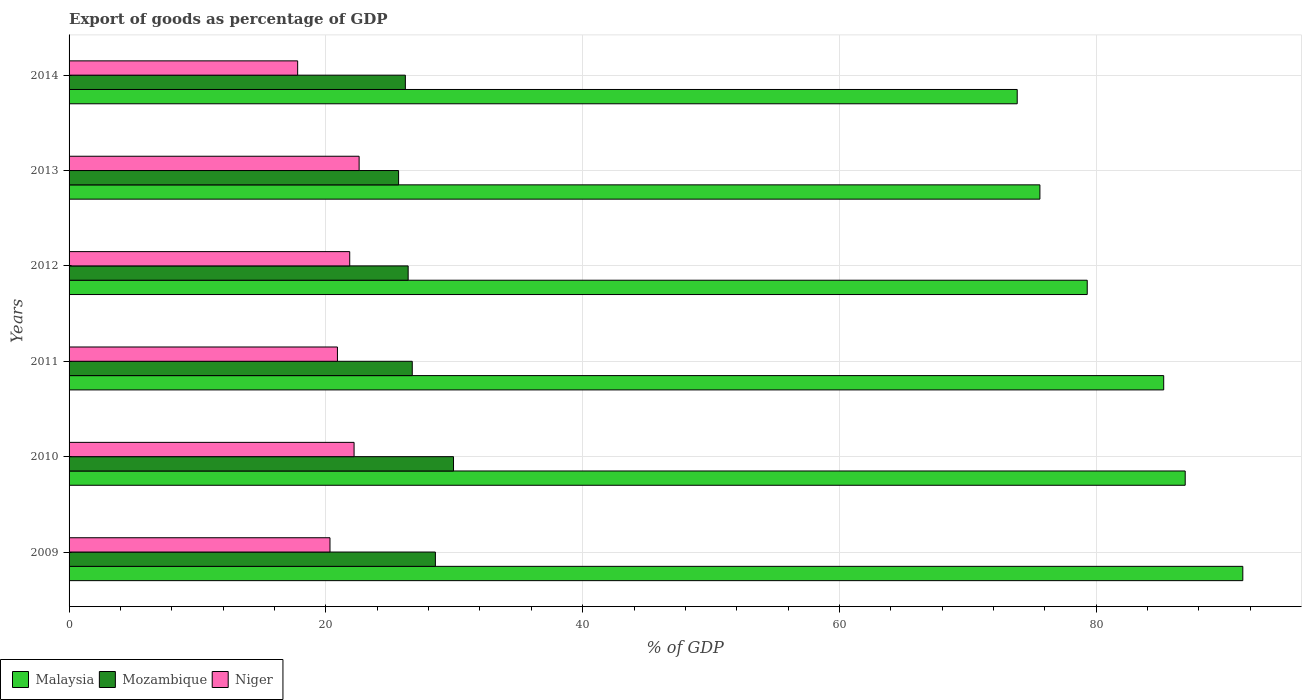How many different coloured bars are there?
Give a very brief answer. 3. How many groups of bars are there?
Keep it short and to the point. 6. Are the number of bars per tick equal to the number of legend labels?
Your answer should be compact. Yes. How many bars are there on the 1st tick from the top?
Provide a succinct answer. 3. What is the label of the 3rd group of bars from the top?
Ensure brevity in your answer.  2012. What is the export of goods as percentage of GDP in Malaysia in 2014?
Give a very brief answer. 73.85. Across all years, what is the maximum export of goods as percentage of GDP in Mozambique?
Your answer should be very brief. 29.94. Across all years, what is the minimum export of goods as percentage of GDP in Niger?
Offer a very short reply. 17.8. In which year was the export of goods as percentage of GDP in Malaysia maximum?
Keep it short and to the point. 2009. What is the total export of goods as percentage of GDP in Niger in the graph?
Provide a succinct answer. 125.68. What is the difference between the export of goods as percentage of GDP in Niger in 2009 and that in 2011?
Offer a terse response. -0.58. What is the difference between the export of goods as percentage of GDP in Mozambique in 2009 and the export of goods as percentage of GDP in Malaysia in 2014?
Offer a very short reply. -45.32. What is the average export of goods as percentage of GDP in Niger per year?
Offer a very short reply. 20.95. In the year 2014, what is the difference between the export of goods as percentage of GDP in Malaysia and export of goods as percentage of GDP in Mozambique?
Offer a very short reply. 47.65. What is the ratio of the export of goods as percentage of GDP in Niger in 2012 to that in 2013?
Provide a short and direct response. 0.97. Is the export of goods as percentage of GDP in Niger in 2011 less than that in 2014?
Provide a short and direct response. No. What is the difference between the highest and the second highest export of goods as percentage of GDP in Mozambique?
Provide a short and direct response. 1.41. What is the difference between the highest and the lowest export of goods as percentage of GDP in Mozambique?
Provide a succinct answer. 4.28. What does the 3rd bar from the top in 2010 represents?
Give a very brief answer. Malaysia. What does the 3rd bar from the bottom in 2013 represents?
Offer a terse response. Niger. Is it the case that in every year, the sum of the export of goods as percentage of GDP in Niger and export of goods as percentage of GDP in Mozambique is greater than the export of goods as percentage of GDP in Malaysia?
Give a very brief answer. No. Are all the bars in the graph horizontal?
Your response must be concise. Yes. How many years are there in the graph?
Make the answer very short. 6. What is the difference between two consecutive major ticks on the X-axis?
Offer a terse response. 20. Does the graph contain grids?
Your response must be concise. Yes. Where does the legend appear in the graph?
Make the answer very short. Bottom left. How many legend labels are there?
Provide a succinct answer. 3. How are the legend labels stacked?
Provide a short and direct response. Horizontal. What is the title of the graph?
Provide a succinct answer. Export of goods as percentage of GDP. What is the label or title of the X-axis?
Provide a succinct answer. % of GDP. What is the label or title of the Y-axis?
Your response must be concise. Years. What is the % of GDP of Malaysia in 2009?
Provide a short and direct response. 91.42. What is the % of GDP in Mozambique in 2009?
Your response must be concise. 28.53. What is the % of GDP in Niger in 2009?
Offer a very short reply. 20.32. What is the % of GDP of Malaysia in 2010?
Make the answer very short. 86.93. What is the % of GDP of Mozambique in 2010?
Give a very brief answer. 29.94. What is the % of GDP in Niger in 2010?
Your response must be concise. 22.2. What is the % of GDP of Malaysia in 2011?
Your answer should be very brief. 85.26. What is the % of GDP of Mozambique in 2011?
Give a very brief answer. 26.73. What is the % of GDP of Niger in 2011?
Make the answer very short. 20.9. What is the % of GDP of Malaysia in 2012?
Make the answer very short. 79.3. What is the % of GDP of Mozambique in 2012?
Offer a very short reply. 26.41. What is the % of GDP of Niger in 2012?
Provide a succinct answer. 21.86. What is the % of GDP of Malaysia in 2013?
Your answer should be compact. 75.61. What is the % of GDP in Mozambique in 2013?
Ensure brevity in your answer.  25.67. What is the % of GDP of Niger in 2013?
Your answer should be compact. 22.59. What is the % of GDP of Malaysia in 2014?
Make the answer very short. 73.85. What is the % of GDP of Mozambique in 2014?
Give a very brief answer. 26.19. What is the % of GDP in Niger in 2014?
Your answer should be very brief. 17.8. Across all years, what is the maximum % of GDP of Malaysia?
Your response must be concise. 91.42. Across all years, what is the maximum % of GDP of Mozambique?
Provide a succinct answer. 29.94. Across all years, what is the maximum % of GDP of Niger?
Provide a succinct answer. 22.59. Across all years, what is the minimum % of GDP in Malaysia?
Provide a succinct answer. 73.85. Across all years, what is the minimum % of GDP in Mozambique?
Ensure brevity in your answer.  25.67. Across all years, what is the minimum % of GDP in Niger?
Offer a very short reply. 17.8. What is the total % of GDP of Malaysia in the graph?
Provide a succinct answer. 492.36. What is the total % of GDP in Mozambique in the graph?
Your answer should be very brief. 163.47. What is the total % of GDP in Niger in the graph?
Your answer should be very brief. 125.68. What is the difference between the % of GDP of Malaysia in 2009 and that in 2010?
Your answer should be very brief. 4.49. What is the difference between the % of GDP of Mozambique in 2009 and that in 2010?
Make the answer very short. -1.41. What is the difference between the % of GDP in Niger in 2009 and that in 2010?
Your answer should be very brief. -1.88. What is the difference between the % of GDP in Malaysia in 2009 and that in 2011?
Keep it short and to the point. 6.16. What is the difference between the % of GDP in Mozambique in 2009 and that in 2011?
Offer a very short reply. 1.8. What is the difference between the % of GDP of Niger in 2009 and that in 2011?
Make the answer very short. -0.58. What is the difference between the % of GDP in Malaysia in 2009 and that in 2012?
Provide a short and direct response. 12.12. What is the difference between the % of GDP of Mozambique in 2009 and that in 2012?
Make the answer very short. 2.12. What is the difference between the % of GDP of Niger in 2009 and that in 2012?
Your response must be concise. -1.54. What is the difference between the % of GDP in Malaysia in 2009 and that in 2013?
Make the answer very short. 15.8. What is the difference between the % of GDP of Mozambique in 2009 and that in 2013?
Offer a very short reply. 2.87. What is the difference between the % of GDP in Niger in 2009 and that in 2013?
Your response must be concise. -2.27. What is the difference between the % of GDP in Malaysia in 2009 and that in 2014?
Offer a very short reply. 17.57. What is the difference between the % of GDP in Mozambique in 2009 and that in 2014?
Give a very brief answer. 2.34. What is the difference between the % of GDP in Niger in 2009 and that in 2014?
Your response must be concise. 2.52. What is the difference between the % of GDP in Malaysia in 2010 and that in 2011?
Give a very brief answer. 1.67. What is the difference between the % of GDP of Mozambique in 2010 and that in 2011?
Your answer should be very brief. 3.21. What is the difference between the % of GDP of Niger in 2010 and that in 2011?
Your answer should be very brief. 1.3. What is the difference between the % of GDP of Malaysia in 2010 and that in 2012?
Ensure brevity in your answer.  7.63. What is the difference between the % of GDP in Mozambique in 2010 and that in 2012?
Your response must be concise. 3.53. What is the difference between the % of GDP of Niger in 2010 and that in 2012?
Your response must be concise. 0.34. What is the difference between the % of GDP in Malaysia in 2010 and that in 2013?
Offer a very short reply. 11.32. What is the difference between the % of GDP in Mozambique in 2010 and that in 2013?
Give a very brief answer. 4.28. What is the difference between the % of GDP in Niger in 2010 and that in 2013?
Keep it short and to the point. -0.39. What is the difference between the % of GDP in Malaysia in 2010 and that in 2014?
Give a very brief answer. 13.08. What is the difference between the % of GDP in Mozambique in 2010 and that in 2014?
Offer a terse response. 3.75. What is the difference between the % of GDP in Niger in 2010 and that in 2014?
Offer a very short reply. 4.39. What is the difference between the % of GDP of Malaysia in 2011 and that in 2012?
Offer a terse response. 5.96. What is the difference between the % of GDP in Mozambique in 2011 and that in 2012?
Provide a succinct answer. 0.32. What is the difference between the % of GDP of Niger in 2011 and that in 2012?
Offer a very short reply. -0.96. What is the difference between the % of GDP of Malaysia in 2011 and that in 2013?
Provide a short and direct response. 9.64. What is the difference between the % of GDP of Mozambique in 2011 and that in 2013?
Your answer should be very brief. 1.06. What is the difference between the % of GDP of Niger in 2011 and that in 2013?
Your answer should be compact. -1.69. What is the difference between the % of GDP of Malaysia in 2011 and that in 2014?
Offer a terse response. 11.41. What is the difference between the % of GDP in Mozambique in 2011 and that in 2014?
Keep it short and to the point. 0.54. What is the difference between the % of GDP in Niger in 2011 and that in 2014?
Give a very brief answer. 3.1. What is the difference between the % of GDP in Malaysia in 2012 and that in 2013?
Your response must be concise. 3.69. What is the difference between the % of GDP in Mozambique in 2012 and that in 2013?
Provide a succinct answer. 0.74. What is the difference between the % of GDP in Niger in 2012 and that in 2013?
Give a very brief answer. -0.73. What is the difference between the % of GDP of Malaysia in 2012 and that in 2014?
Offer a very short reply. 5.45. What is the difference between the % of GDP of Mozambique in 2012 and that in 2014?
Your answer should be very brief. 0.22. What is the difference between the % of GDP in Niger in 2012 and that in 2014?
Provide a short and direct response. 4.05. What is the difference between the % of GDP of Malaysia in 2013 and that in 2014?
Ensure brevity in your answer.  1.77. What is the difference between the % of GDP in Mozambique in 2013 and that in 2014?
Your answer should be very brief. -0.53. What is the difference between the % of GDP in Niger in 2013 and that in 2014?
Keep it short and to the point. 4.79. What is the difference between the % of GDP of Malaysia in 2009 and the % of GDP of Mozambique in 2010?
Offer a terse response. 61.47. What is the difference between the % of GDP of Malaysia in 2009 and the % of GDP of Niger in 2010?
Your response must be concise. 69.22. What is the difference between the % of GDP in Mozambique in 2009 and the % of GDP in Niger in 2010?
Your answer should be compact. 6.33. What is the difference between the % of GDP of Malaysia in 2009 and the % of GDP of Mozambique in 2011?
Your answer should be very brief. 64.69. What is the difference between the % of GDP of Malaysia in 2009 and the % of GDP of Niger in 2011?
Offer a very short reply. 70.51. What is the difference between the % of GDP in Mozambique in 2009 and the % of GDP in Niger in 2011?
Keep it short and to the point. 7.63. What is the difference between the % of GDP in Malaysia in 2009 and the % of GDP in Mozambique in 2012?
Provide a succinct answer. 65.01. What is the difference between the % of GDP of Malaysia in 2009 and the % of GDP of Niger in 2012?
Offer a very short reply. 69.56. What is the difference between the % of GDP of Mozambique in 2009 and the % of GDP of Niger in 2012?
Give a very brief answer. 6.67. What is the difference between the % of GDP in Malaysia in 2009 and the % of GDP in Mozambique in 2013?
Offer a very short reply. 65.75. What is the difference between the % of GDP of Malaysia in 2009 and the % of GDP of Niger in 2013?
Offer a very short reply. 68.83. What is the difference between the % of GDP of Mozambique in 2009 and the % of GDP of Niger in 2013?
Ensure brevity in your answer.  5.94. What is the difference between the % of GDP of Malaysia in 2009 and the % of GDP of Mozambique in 2014?
Your answer should be compact. 65.22. What is the difference between the % of GDP in Malaysia in 2009 and the % of GDP in Niger in 2014?
Make the answer very short. 73.61. What is the difference between the % of GDP in Mozambique in 2009 and the % of GDP in Niger in 2014?
Make the answer very short. 10.73. What is the difference between the % of GDP of Malaysia in 2010 and the % of GDP of Mozambique in 2011?
Offer a terse response. 60.2. What is the difference between the % of GDP of Malaysia in 2010 and the % of GDP of Niger in 2011?
Provide a short and direct response. 66.03. What is the difference between the % of GDP of Mozambique in 2010 and the % of GDP of Niger in 2011?
Offer a terse response. 9.04. What is the difference between the % of GDP in Malaysia in 2010 and the % of GDP in Mozambique in 2012?
Your answer should be compact. 60.52. What is the difference between the % of GDP of Malaysia in 2010 and the % of GDP of Niger in 2012?
Provide a short and direct response. 65.07. What is the difference between the % of GDP of Mozambique in 2010 and the % of GDP of Niger in 2012?
Provide a succinct answer. 8.08. What is the difference between the % of GDP of Malaysia in 2010 and the % of GDP of Mozambique in 2013?
Offer a terse response. 61.26. What is the difference between the % of GDP in Malaysia in 2010 and the % of GDP in Niger in 2013?
Provide a short and direct response. 64.34. What is the difference between the % of GDP of Mozambique in 2010 and the % of GDP of Niger in 2013?
Make the answer very short. 7.35. What is the difference between the % of GDP in Malaysia in 2010 and the % of GDP in Mozambique in 2014?
Keep it short and to the point. 60.74. What is the difference between the % of GDP of Malaysia in 2010 and the % of GDP of Niger in 2014?
Make the answer very short. 69.13. What is the difference between the % of GDP of Mozambique in 2010 and the % of GDP of Niger in 2014?
Your answer should be very brief. 12.14. What is the difference between the % of GDP in Malaysia in 2011 and the % of GDP in Mozambique in 2012?
Your response must be concise. 58.85. What is the difference between the % of GDP in Malaysia in 2011 and the % of GDP in Niger in 2012?
Your response must be concise. 63.4. What is the difference between the % of GDP of Mozambique in 2011 and the % of GDP of Niger in 2012?
Give a very brief answer. 4.87. What is the difference between the % of GDP of Malaysia in 2011 and the % of GDP of Mozambique in 2013?
Make the answer very short. 59.59. What is the difference between the % of GDP of Malaysia in 2011 and the % of GDP of Niger in 2013?
Your response must be concise. 62.66. What is the difference between the % of GDP in Mozambique in 2011 and the % of GDP in Niger in 2013?
Your answer should be compact. 4.14. What is the difference between the % of GDP of Malaysia in 2011 and the % of GDP of Mozambique in 2014?
Give a very brief answer. 59.06. What is the difference between the % of GDP of Malaysia in 2011 and the % of GDP of Niger in 2014?
Your answer should be very brief. 67.45. What is the difference between the % of GDP in Mozambique in 2011 and the % of GDP in Niger in 2014?
Ensure brevity in your answer.  8.93. What is the difference between the % of GDP of Malaysia in 2012 and the % of GDP of Mozambique in 2013?
Your answer should be compact. 53.63. What is the difference between the % of GDP in Malaysia in 2012 and the % of GDP in Niger in 2013?
Offer a terse response. 56.71. What is the difference between the % of GDP of Mozambique in 2012 and the % of GDP of Niger in 2013?
Your answer should be very brief. 3.82. What is the difference between the % of GDP of Malaysia in 2012 and the % of GDP of Mozambique in 2014?
Provide a short and direct response. 53.11. What is the difference between the % of GDP of Malaysia in 2012 and the % of GDP of Niger in 2014?
Provide a succinct answer. 61.5. What is the difference between the % of GDP of Mozambique in 2012 and the % of GDP of Niger in 2014?
Your answer should be compact. 8.61. What is the difference between the % of GDP in Malaysia in 2013 and the % of GDP in Mozambique in 2014?
Give a very brief answer. 49.42. What is the difference between the % of GDP in Malaysia in 2013 and the % of GDP in Niger in 2014?
Your response must be concise. 57.81. What is the difference between the % of GDP of Mozambique in 2013 and the % of GDP of Niger in 2014?
Your response must be concise. 7.86. What is the average % of GDP of Malaysia per year?
Your response must be concise. 82.06. What is the average % of GDP in Mozambique per year?
Your response must be concise. 27.25. What is the average % of GDP of Niger per year?
Your answer should be compact. 20.95. In the year 2009, what is the difference between the % of GDP in Malaysia and % of GDP in Mozambique?
Provide a short and direct response. 62.89. In the year 2009, what is the difference between the % of GDP of Malaysia and % of GDP of Niger?
Make the answer very short. 71.1. In the year 2009, what is the difference between the % of GDP of Mozambique and % of GDP of Niger?
Your response must be concise. 8.21. In the year 2010, what is the difference between the % of GDP of Malaysia and % of GDP of Mozambique?
Make the answer very short. 56.99. In the year 2010, what is the difference between the % of GDP of Malaysia and % of GDP of Niger?
Ensure brevity in your answer.  64.73. In the year 2010, what is the difference between the % of GDP of Mozambique and % of GDP of Niger?
Keep it short and to the point. 7.74. In the year 2011, what is the difference between the % of GDP of Malaysia and % of GDP of Mozambique?
Provide a succinct answer. 58.53. In the year 2011, what is the difference between the % of GDP in Malaysia and % of GDP in Niger?
Offer a terse response. 64.35. In the year 2011, what is the difference between the % of GDP of Mozambique and % of GDP of Niger?
Your answer should be compact. 5.83. In the year 2012, what is the difference between the % of GDP in Malaysia and % of GDP in Mozambique?
Offer a terse response. 52.89. In the year 2012, what is the difference between the % of GDP of Malaysia and % of GDP of Niger?
Your answer should be compact. 57.44. In the year 2012, what is the difference between the % of GDP of Mozambique and % of GDP of Niger?
Your response must be concise. 4.55. In the year 2013, what is the difference between the % of GDP in Malaysia and % of GDP in Mozambique?
Provide a succinct answer. 49.95. In the year 2013, what is the difference between the % of GDP of Malaysia and % of GDP of Niger?
Your answer should be very brief. 53.02. In the year 2013, what is the difference between the % of GDP of Mozambique and % of GDP of Niger?
Your answer should be compact. 3.07. In the year 2014, what is the difference between the % of GDP of Malaysia and % of GDP of Mozambique?
Keep it short and to the point. 47.65. In the year 2014, what is the difference between the % of GDP of Malaysia and % of GDP of Niger?
Your answer should be compact. 56.04. In the year 2014, what is the difference between the % of GDP in Mozambique and % of GDP in Niger?
Your answer should be very brief. 8.39. What is the ratio of the % of GDP in Malaysia in 2009 to that in 2010?
Your answer should be very brief. 1.05. What is the ratio of the % of GDP in Mozambique in 2009 to that in 2010?
Give a very brief answer. 0.95. What is the ratio of the % of GDP in Niger in 2009 to that in 2010?
Make the answer very short. 0.92. What is the ratio of the % of GDP of Malaysia in 2009 to that in 2011?
Ensure brevity in your answer.  1.07. What is the ratio of the % of GDP of Mozambique in 2009 to that in 2011?
Your answer should be compact. 1.07. What is the ratio of the % of GDP of Niger in 2009 to that in 2011?
Your answer should be very brief. 0.97. What is the ratio of the % of GDP of Malaysia in 2009 to that in 2012?
Ensure brevity in your answer.  1.15. What is the ratio of the % of GDP in Mozambique in 2009 to that in 2012?
Your response must be concise. 1.08. What is the ratio of the % of GDP of Niger in 2009 to that in 2012?
Your answer should be compact. 0.93. What is the ratio of the % of GDP in Malaysia in 2009 to that in 2013?
Keep it short and to the point. 1.21. What is the ratio of the % of GDP of Mozambique in 2009 to that in 2013?
Your response must be concise. 1.11. What is the ratio of the % of GDP in Niger in 2009 to that in 2013?
Your answer should be very brief. 0.9. What is the ratio of the % of GDP in Malaysia in 2009 to that in 2014?
Make the answer very short. 1.24. What is the ratio of the % of GDP of Mozambique in 2009 to that in 2014?
Provide a succinct answer. 1.09. What is the ratio of the % of GDP of Niger in 2009 to that in 2014?
Offer a very short reply. 1.14. What is the ratio of the % of GDP of Malaysia in 2010 to that in 2011?
Provide a short and direct response. 1.02. What is the ratio of the % of GDP of Mozambique in 2010 to that in 2011?
Offer a very short reply. 1.12. What is the ratio of the % of GDP in Niger in 2010 to that in 2011?
Keep it short and to the point. 1.06. What is the ratio of the % of GDP in Malaysia in 2010 to that in 2012?
Provide a short and direct response. 1.1. What is the ratio of the % of GDP of Mozambique in 2010 to that in 2012?
Your response must be concise. 1.13. What is the ratio of the % of GDP in Niger in 2010 to that in 2012?
Provide a short and direct response. 1.02. What is the ratio of the % of GDP in Malaysia in 2010 to that in 2013?
Make the answer very short. 1.15. What is the ratio of the % of GDP of Mozambique in 2010 to that in 2013?
Make the answer very short. 1.17. What is the ratio of the % of GDP in Niger in 2010 to that in 2013?
Provide a short and direct response. 0.98. What is the ratio of the % of GDP of Malaysia in 2010 to that in 2014?
Your answer should be very brief. 1.18. What is the ratio of the % of GDP of Mozambique in 2010 to that in 2014?
Your response must be concise. 1.14. What is the ratio of the % of GDP of Niger in 2010 to that in 2014?
Make the answer very short. 1.25. What is the ratio of the % of GDP in Malaysia in 2011 to that in 2012?
Your response must be concise. 1.08. What is the ratio of the % of GDP of Mozambique in 2011 to that in 2012?
Offer a very short reply. 1.01. What is the ratio of the % of GDP in Niger in 2011 to that in 2012?
Give a very brief answer. 0.96. What is the ratio of the % of GDP in Malaysia in 2011 to that in 2013?
Make the answer very short. 1.13. What is the ratio of the % of GDP in Mozambique in 2011 to that in 2013?
Your answer should be very brief. 1.04. What is the ratio of the % of GDP in Niger in 2011 to that in 2013?
Ensure brevity in your answer.  0.93. What is the ratio of the % of GDP of Malaysia in 2011 to that in 2014?
Your response must be concise. 1.15. What is the ratio of the % of GDP of Mozambique in 2011 to that in 2014?
Offer a very short reply. 1.02. What is the ratio of the % of GDP of Niger in 2011 to that in 2014?
Make the answer very short. 1.17. What is the ratio of the % of GDP of Malaysia in 2012 to that in 2013?
Offer a terse response. 1.05. What is the ratio of the % of GDP of Mozambique in 2012 to that in 2013?
Keep it short and to the point. 1.03. What is the ratio of the % of GDP of Niger in 2012 to that in 2013?
Your response must be concise. 0.97. What is the ratio of the % of GDP in Malaysia in 2012 to that in 2014?
Provide a short and direct response. 1.07. What is the ratio of the % of GDP in Mozambique in 2012 to that in 2014?
Provide a short and direct response. 1.01. What is the ratio of the % of GDP in Niger in 2012 to that in 2014?
Ensure brevity in your answer.  1.23. What is the ratio of the % of GDP in Malaysia in 2013 to that in 2014?
Your answer should be very brief. 1.02. What is the ratio of the % of GDP in Mozambique in 2013 to that in 2014?
Your answer should be compact. 0.98. What is the ratio of the % of GDP in Niger in 2013 to that in 2014?
Ensure brevity in your answer.  1.27. What is the difference between the highest and the second highest % of GDP of Malaysia?
Offer a terse response. 4.49. What is the difference between the highest and the second highest % of GDP of Mozambique?
Provide a succinct answer. 1.41. What is the difference between the highest and the second highest % of GDP in Niger?
Your answer should be very brief. 0.39. What is the difference between the highest and the lowest % of GDP of Malaysia?
Offer a terse response. 17.57. What is the difference between the highest and the lowest % of GDP in Mozambique?
Provide a succinct answer. 4.28. What is the difference between the highest and the lowest % of GDP of Niger?
Provide a succinct answer. 4.79. 